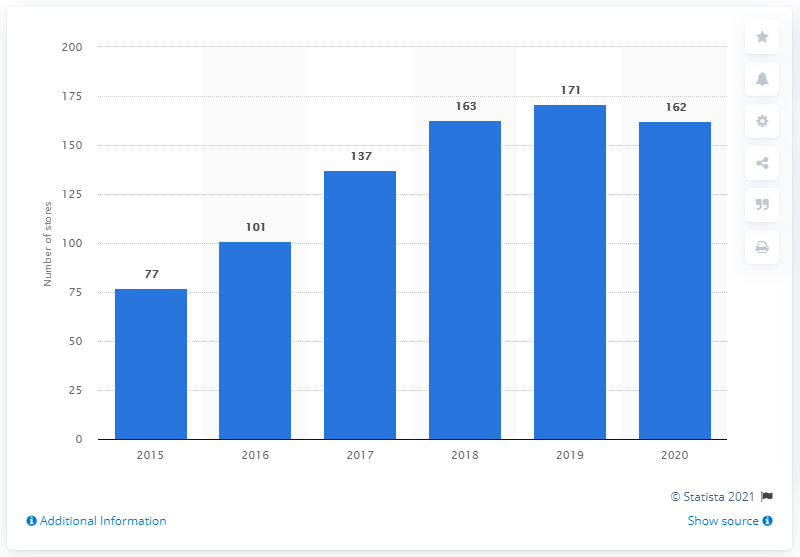Mention a couple of crucial points in this snapshot. In 2020, Macy's had a total of 162 Bluemercury stores. 